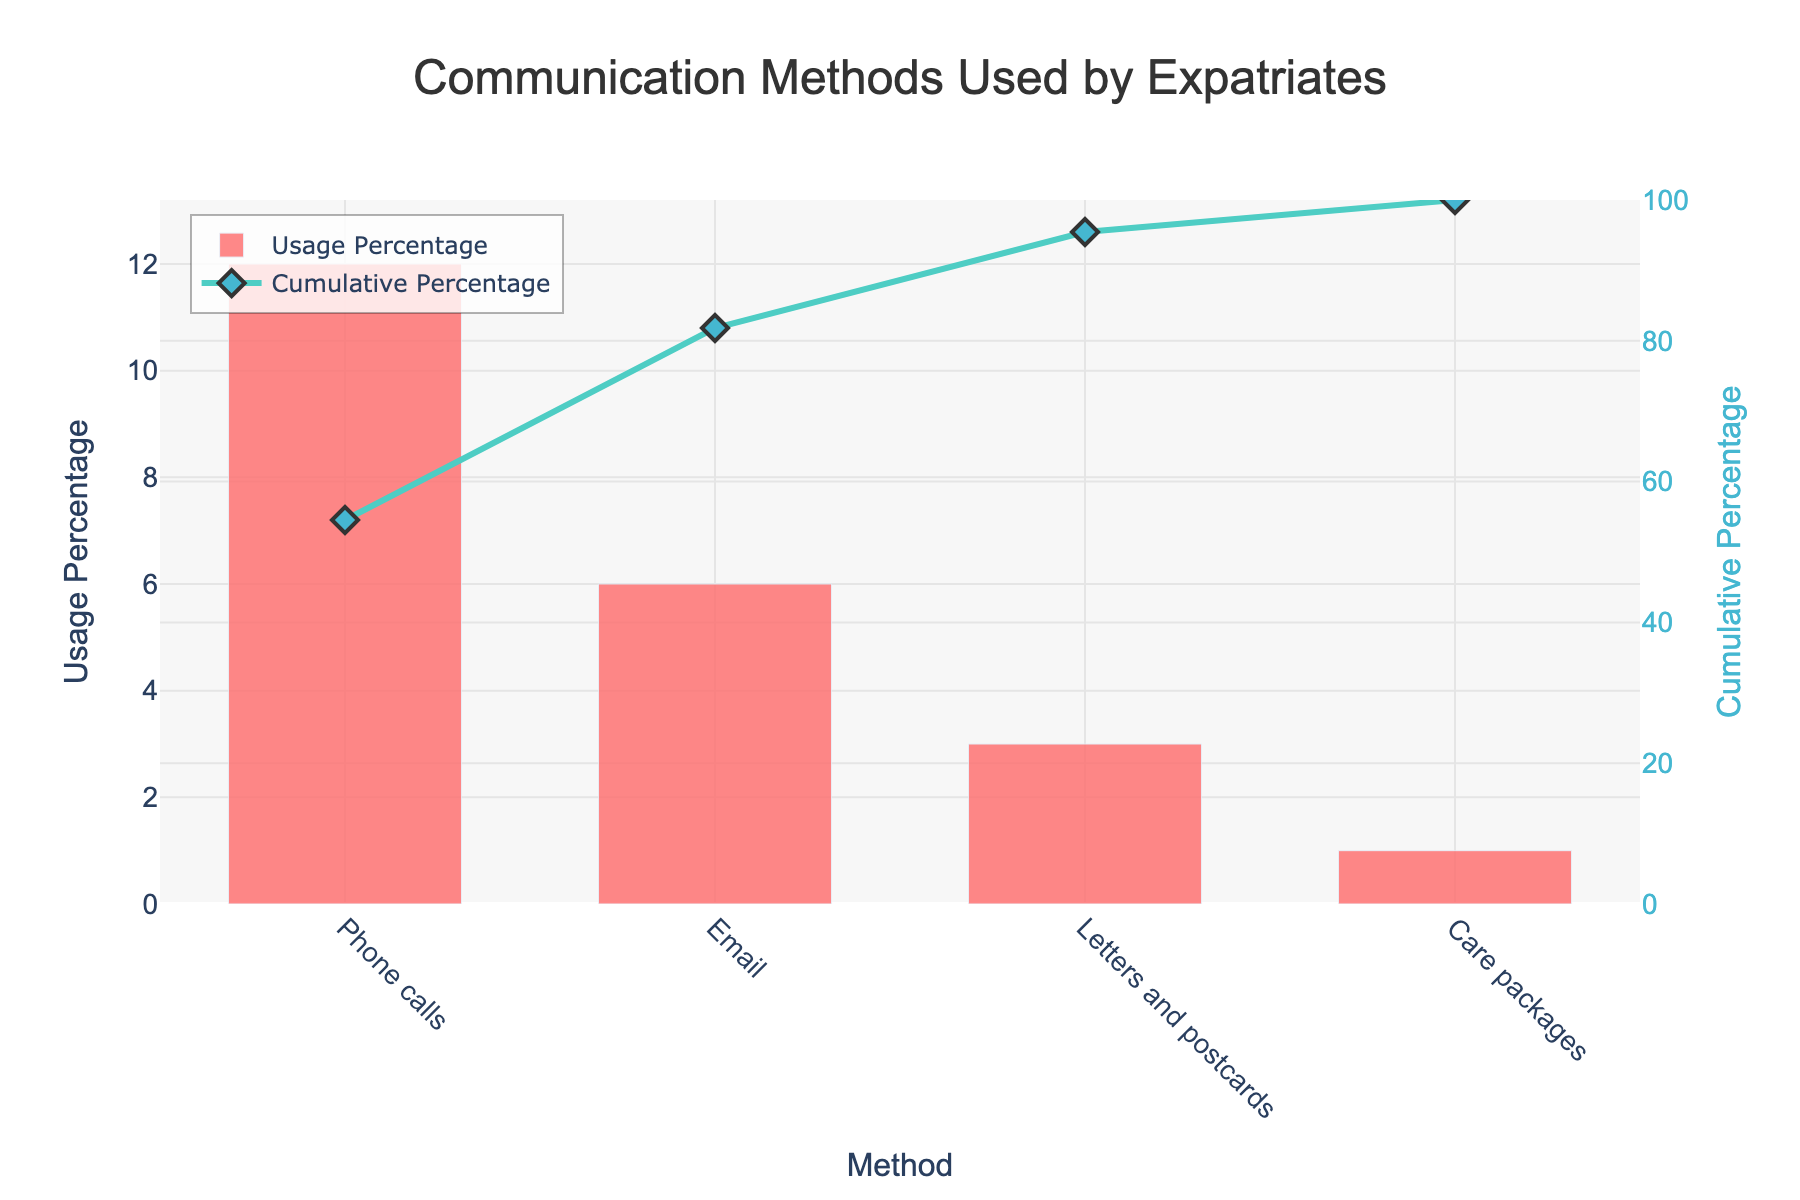What's the title of the figure? The title of the figure is displayed at the top center. It reads "Communication Methods Used by Expatriates."
Answer: Communication Methods Used by Expatriates Which communication method is used the most by expatriates? By looking at the highest bar in the bar chart, the method with the largest usage percentage is the most used. It is "Phone calls" with 12%.
Answer: Phone calls What is the usage percentage of letters and postcards? Locate the bar corresponding to "Letters and postcards" and read the height of the bar on the y-axis, which indicates it is 3%.
Answer: 3% What is the cumulative percentage after including email? The cumulative percentage is marked by the line and points in the chart. After "Email," the cumulative percentage reaches 18% (12% from phone calls + 6% from email).
Answer: 18% Which method contributes the smallest percentage of usage? Identify the smallest bar in the bar chart which corresponds to the method with the lowest usage percentage. It is "Care packages" with 1%.
Answer: Care packages How many methods are analyzed in the chart? Counting the bars in the bar chart gives the total number of methods analyzed. There are 4 bars.
Answer: 4 Compare the usage percentages of phone calls and emails. The bar for "Phone calls" stands at 12%, while the bar for "Email" stands at 6%. Comparing them shows that phone calls have a higher usage percentage.
Answer: Phone calls have a higher percentage What is the cumulative percentage at the end of the chart? The cumulative percentage at the end is depicted by the line at the last data point, which is 100% as it sums up all methods.
Answer: 100% Which communication method has the second highest usage percentage? By examining the heights of the bars, the second tallest bar corresponds to "Email," which shows a usage percentage of 6%.
Answer: Email What is the color of the cumulative percentage line? The line representing the cumulative percentage in the chart is depicted in a light turquoise color.
Answer: Light turquoise 